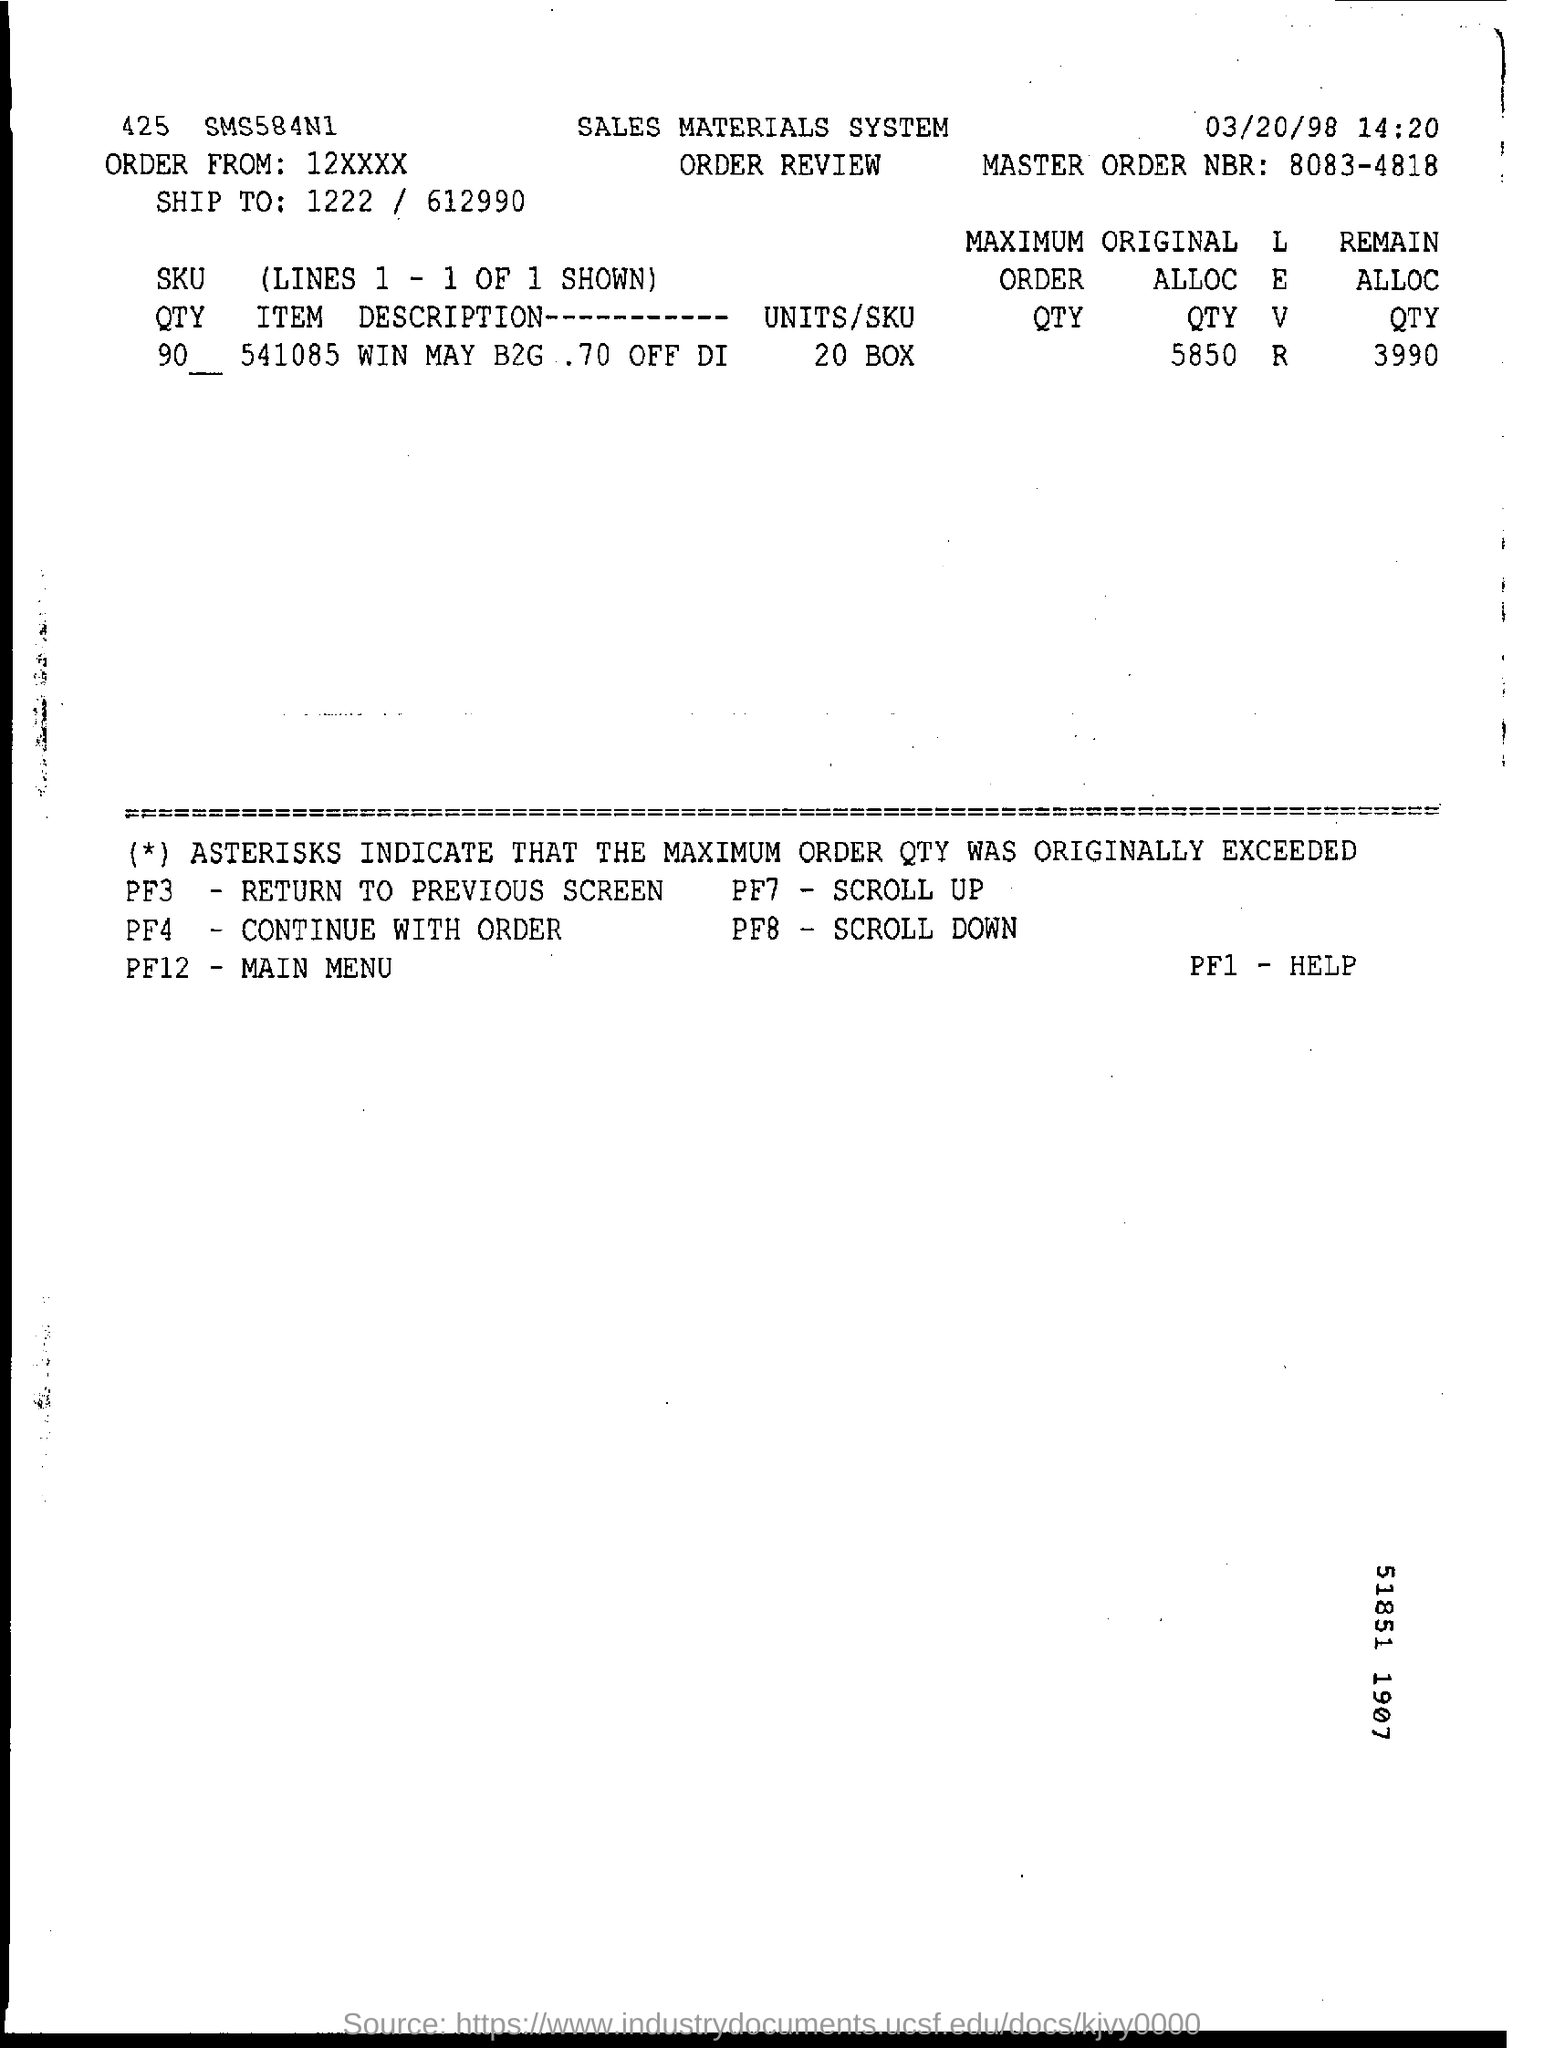What is the master order number?
Ensure brevity in your answer.  8083-4818. What is the item description?
Make the answer very short. 541085 win may b2g . 70 off Di. What is PF3 for?
Give a very brief answer. Return to previous screen. 